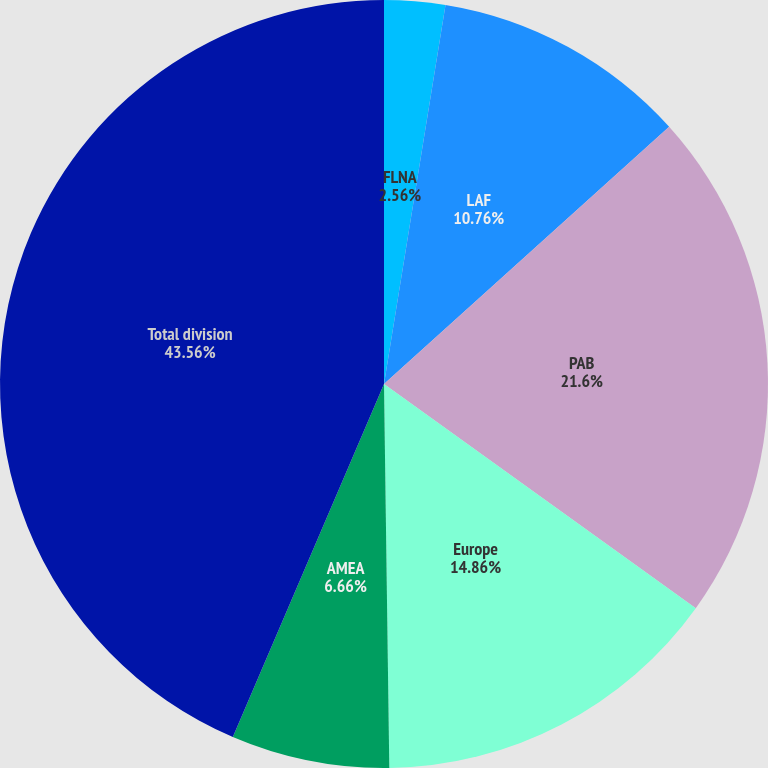<chart> <loc_0><loc_0><loc_500><loc_500><pie_chart><fcel>FLNA<fcel>LAF<fcel>PAB<fcel>Europe<fcel>AMEA<fcel>Total division<nl><fcel>2.56%<fcel>10.76%<fcel>21.6%<fcel>14.86%<fcel>6.66%<fcel>43.56%<nl></chart> 